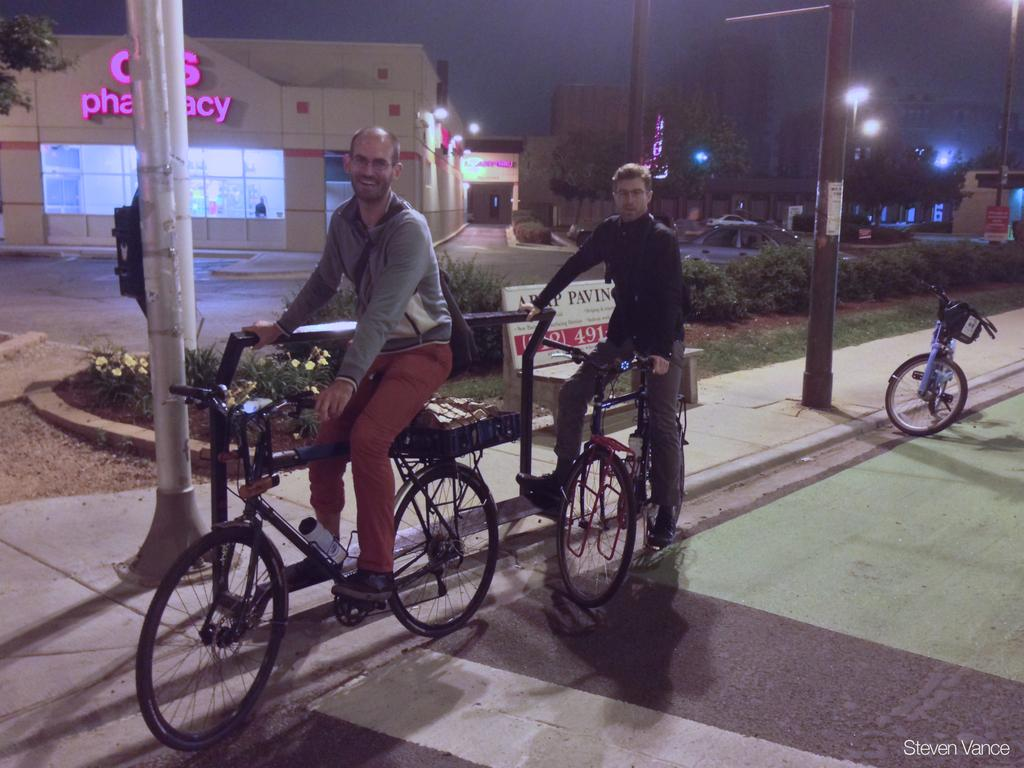How many men are in the image? There are two men in the image. What are the men doing in the image? The men are on a cycle. Can you describe the facial expression of one of the men? One of the men is smiling. Where are the men located in the image? The men are on a path. What can be seen in the background of the image? There are plants, a building, poles, and another cycle in the background of the image. What type of stove can be seen in the image? There is no stove present in the image. What color is the marble on the cycle? There is no marble on the cycle; it is a regular bicycle. 